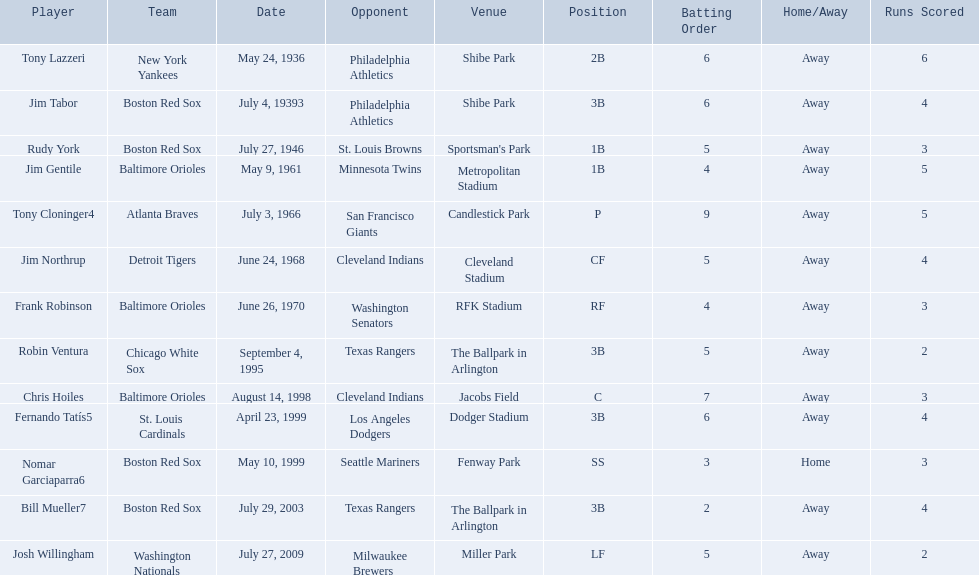What are the names of all the players? Tony Lazzeri, Jim Tabor, Rudy York, Jim Gentile, Tony Cloninger4, Jim Northrup, Frank Robinson, Robin Ventura, Chris Hoiles, Fernando Tatís5, Nomar Garciaparra6, Bill Mueller7, Josh Willingham. What are the names of all the teams holding home run records? New York Yankees, Boston Red Sox, Baltimore Orioles, Atlanta Braves, Detroit Tigers, Chicago White Sox, St. Louis Cardinals, Washington Nationals. Which player played for the new york yankees? Tony Lazzeri. 